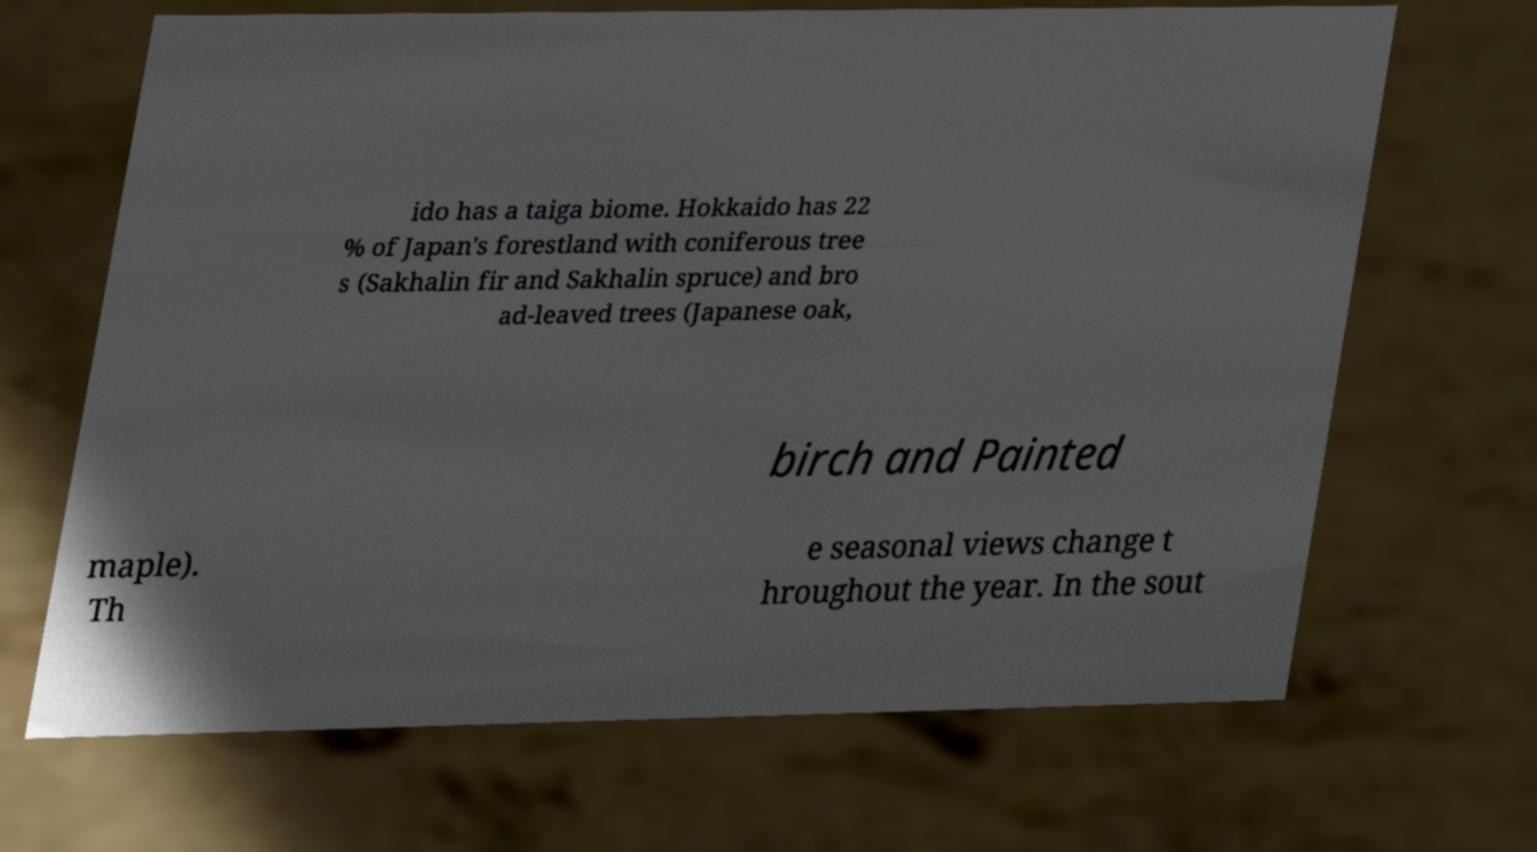Please identify and transcribe the text found in this image. ido has a taiga biome. Hokkaido has 22 % of Japan's forestland with coniferous tree s (Sakhalin fir and Sakhalin spruce) and bro ad-leaved trees (Japanese oak, birch and Painted maple). Th e seasonal views change t hroughout the year. In the sout 